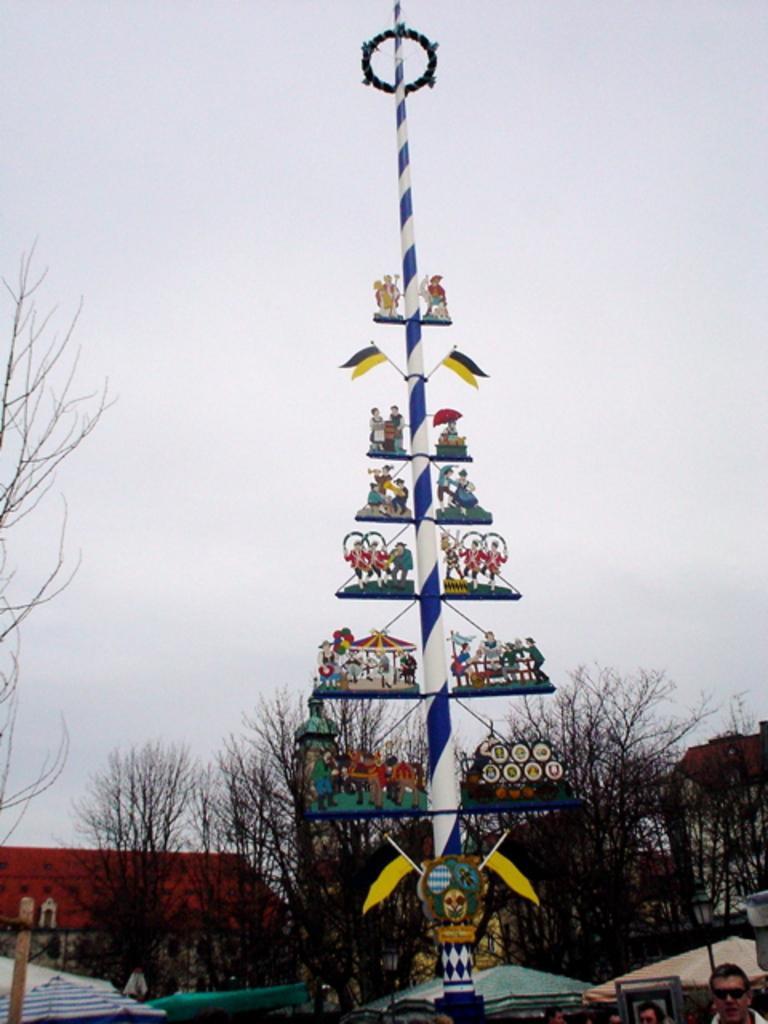Can you describe this image briefly? In the center of the picture there is a pole, on which there are some objects attached. In the background there are trees and buildings. In the middle of the picture there are canopies and people. At the top it is sky. 